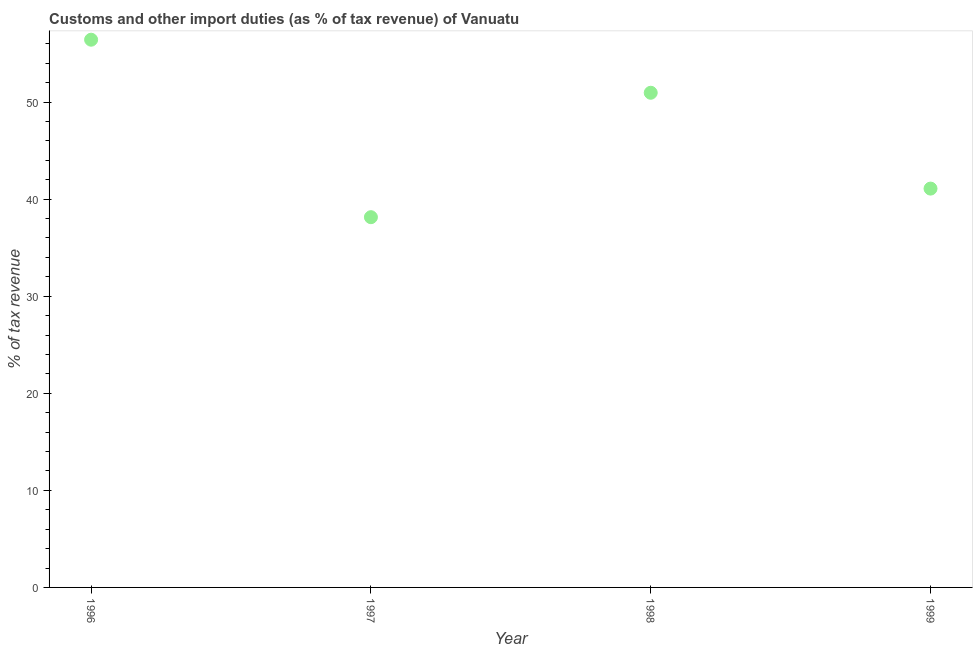What is the customs and other import duties in 1997?
Your response must be concise. 38.14. Across all years, what is the maximum customs and other import duties?
Your answer should be compact. 56.43. Across all years, what is the minimum customs and other import duties?
Keep it short and to the point. 38.14. In which year was the customs and other import duties maximum?
Provide a short and direct response. 1996. What is the sum of the customs and other import duties?
Make the answer very short. 186.62. What is the difference between the customs and other import duties in 1998 and 1999?
Give a very brief answer. 9.87. What is the average customs and other import duties per year?
Offer a very short reply. 46.65. What is the median customs and other import duties?
Make the answer very short. 46.02. What is the ratio of the customs and other import duties in 1996 to that in 1998?
Your answer should be compact. 1.11. What is the difference between the highest and the second highest customs and other import duties?
Offer a very short reply. 5.47. Is the sum of the customs and other import duties in 1997 and 1999 greater than the maximum customs and other import duties across all years?
Your response must be concise. Yes. What is the difference between the highest and the lowest customs and other import duties?
Provide a succinct answer. 18.28. How many dotlines are there?
Offer a terse response. 1. How many years are there in the graph?
Make the answer very short. 4. What is the difference between two consecutive major ticks on the Y-axis?
Keep it short and to the point. 10. What is the title of the graph?
Provide a succinct answer. Customs and other import duties (as % of tax revenue) of Vanuatu. What is the label or title of the Y-axis?
Keep it short and to the point. % of tax revenue. What is the % of tax revenue in 1996?
Ensure brevity in your answer.  56.43. What is the % of tax revenue in 1997?
Provide a short and direct response. 38.14. What is the % of tax revenue in 1998?
Ensure brevity in your answer.  50.96. What is the % of tax revenue in 1999?
Your answer should be compact. 41.09. What is the difference between the % of tax revenue in 1996 and 1997?
Offer a terse response. 18.28. What is the difference between the % of tax revenue in 1996 and 1998?
Your answer should be very brief. 5.47. What is the difference between the % of tax revenue in 1996 and 1999?
Provide a short and direct response. 15.34. What is the difference between the % of tax revenue in 1997 and 1998?
Your response must be concise. -12.82. What is the difference between the % of tax revenue in 1997 and 1999?
Offer a very short reply. -2.94. What is the difference between the % of tax revenue in 1998 and 1999?
Make the answer very short. 9.87. What is the ratio of the % of tax revenue in 1996 to that in 1997?
Offer a very short reply. 1.48. What is the ratio of the % of tax revenue in 1996 to that in 1998?
Ensure brevity in your answer.  1.11. What is the ratio of the % of tax revenue in 1996 to that in 1999?
Provide a succinct answer. 1.37. What is the ratio of the % of tax revenue in 1997 to that in 1998?
Offer a terse response. 0.75. What is the ratio of the % of tax revenue in 1997 to that in 1999?
Your answer should be very brief. 0.93. What is the ratio of the % of tax revenue in 1998 to that in 1999?
Offer a very short reply. 1.24. 